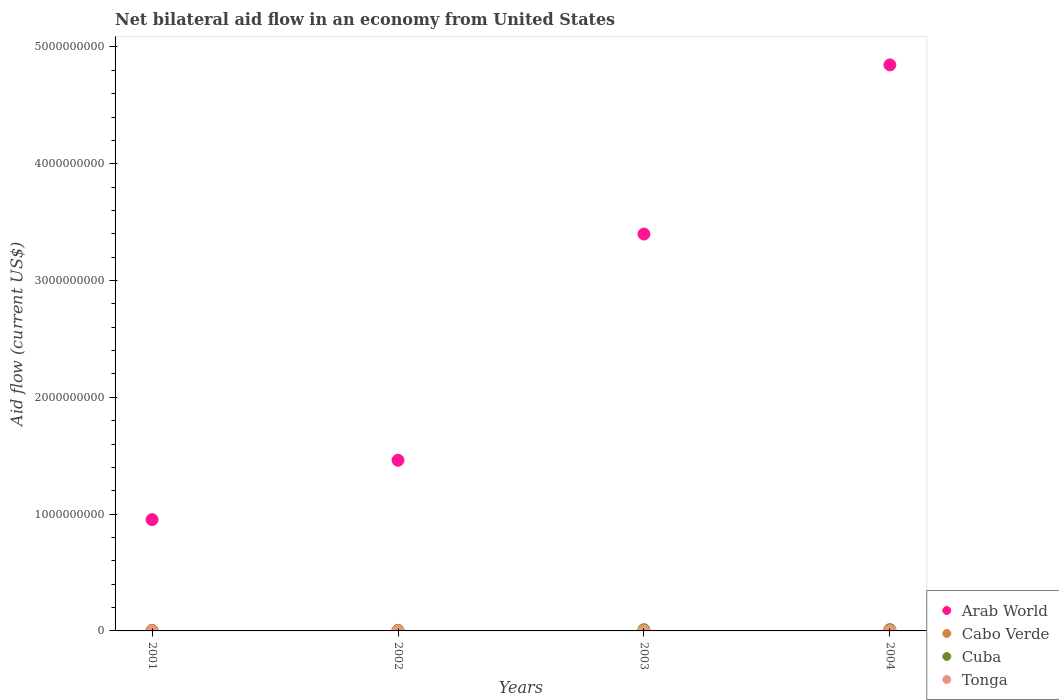How many different coloured dotlines are there?
Your response must be concise. 4. What is the net bilateral aid flow in Arab World in 2004?
Give a very brief answer. 4.85e+09. Across all years, what is the maximum net bilateral aid flow in Arab World?
Keep it short and to the point. 4.85e+09. Across all years, what is the minimum net bilateral aid flow in Tonga?
Ensure brevity in your answer.  9.80e+05. In which year was the net bilateral aid flow in Tonga minimum?
Offer a terse response. 2003. What is the total net bilateral aid flow in Tonga in the graph?
Provide a succinct answer. 4.41e+06. What is the difference between the net bilateral aid flow in Cuba in 2001 and that in 2004?
Make the answer very short. -6.93e+06. What is the difference between the net bilateral aid flow in Cuba in 2003 and the net bilateral aid flow in Cabo Verde in 2001?
Your response must be concise. 5.89e+06. What is the average net bilateral aid flow in Cuba per year?
Give a very brief answer. 7.22e+06. In the year 2003, what is the difference between the net bilateral aid flow in Cabo Verde and net bilateral aid flow in Arab World?
Keep it short and to the point. -3.39e+09. In how many years, is the net bilateral aid flow in Tonga greater than 600000000 US$?
Your answer should be compact. 0. What is the ratio of the net bilateral aid flow in Arab World in 2001 to that in 2002?
Give a very brief answer. 0.65. Is the difference between the net bilateral aid flow in Cabo Verde in 2002 and 2004 greater than the difference between the net bilateral aid flow in Arab World in 2002 and 2004?
Your answer should be very brief. Yes. What is the difference between the highest and the second highest net bilateral aid flow in Cabo Verde?
Your answer should be very brief. 1.04e+06. What is the difference between the highest and the lowest net bilateral aid flow in Cabo Verde?
Make the answer very short. 2.41e+06. Is it the case that in every year, the sum of the net bilateral aid flow in Cuba and net bilateral aid flow in Tonga  is greater than the net bilateral aid flow in Cabo Verde?
Give a very brief answer. Yes. What is the difference between two consecutive major ticks on the Y-axis?
Ensure brevity in your answer.  1.00e+09. How many legend labels are there?
Offer a terse response. 4. What is the title of the graph?
Your answer should be compact. Net bilateral aid flow in an economy from United States. What is the label or title of the X-axis?
Your answer should be compact. Years. What is the Aid flow (current US$) of Arab World in 2001?
Your response must be concise. 9.53e+08. What is the Aid flow (current US$) in Cabo Verde in 2001?
Ensure brevity in your answer.  4.28e+06. What is the Aid flow (current US$) in Cuba in 2001?
Your answer should be very brief. 3.62e+06. What is the Aid flow (current US$) in Tonga in 2001?
Keep it short and to the point. 1.19e+06. What is the Aid flow (current US$) of Arab World in 2002?
Make the answer very short. 1.46e+09. What is the Aid flow (current US$) of Cabo Verde in 2002?
Provide a short and direct response. 5.01e+06. What is the Aid flow (current US$) in Cuba in 2002?
Make the answer very short. 4.55e+06. What is the Aid flow (current US$) in Tonga in 2002?
Your answer should be compact. 1.15e+06. What is the Aid flow (current US$) of Arab World in 2003?
Offer a very short reply. 3.40e+09. What is the Aid flow (current US$) in Cabo Verde in 2003?
Offer a terse response. 5.65e+06. What is the Aid flow (current US$) in Cuba in 2003?
Keep it short and to the point. 1.02e+07. What is the Aid flow (current US$) of Tonga in 2003?
Ensure brevity in your answer.  9.80e+05. What is the Aid flow (current US$) of Arab World in 2004?
Offer a very short reply. 4.85e+09. What is the Aid flow (current US$) in Cabo Verde in 2004?
Provide a succinct answer. 6.69e+06. What is the Aid flow (current US$) in Cuba in 2004?
Your response must be concise. 1.06e+07. What is the Aid flow (current US$) in Tonga in 2004?
Make the answer very short. 1.09e+06. Across all years, what is the maximum Aid flow (current US$) in Arab World?
Your answer should be compact. 4.85e+09. Across all years, what is the maximum Aid flow (current US$) in Cabo Verde?
Offer a terse response. 6.69e+06. Across all years, what is the maximum Aid flow (current US$) of Cuba?
Offer a terse response. 1.06e+07. Across all years, what is the maximum Aid flow (current US$) in Tonga?
Your answer should be compact. 1.19e+06. Across all years, what is the minimum Aid flow (current US$) of Arab World?
Your answer should be very brief. 9.53e+08. Across all years, what is the minimum Aid flow (current US$) of Cabo Verde?
Your answer should be very brief. 4.28e+06. Across all years, what is the minimum Aid flow (current US$) of Cuba?
Your answer should be compact. 3.62e+06. Across all years, what is the minimum Aid flow (current US$) in Tonga?
Your response must be concise. 9.80e+05. What is the total Aid flow (current US$) in Arab World in the graph?
Offer a terse response. 1.07e+1. What is the total Aid flow (current US$) of Cabo Verde in the graph?
Your answer should be very brief. 2.16e+07. What is the total Aid flow (current US$) in Cuba in the graph?
Provide a succinct answer. 2.89e+07. What is the total Aid flow (current US$) of Tonga in the graph?
Keep it short and to the point. 4.41e+06. What is the difference between the Aid flow (current US$) in Arab World in 2001 and that in 2002?
Keep it short and to the point. -5.08e+08. What is the difference between the Aid flow (current US$) of Cabo Verde in 2001 and that in 2002?
Offer a terse response. -7.30e+05. What is the difference between the Aid flow (current US$) in Cuba in 2001 and that in 2002?
Your answer should be very brief. -9.30e+05. What is the difference between the Aid flow (current US$) in Tonga in 2001 and that in 2002?
Provide a short and direct response. 4.00e+04. What is the difference between the Aid flow (current US$) in Arab World in 2001 and that in 2003?
Make the answer very short. -2.45e+09. What is the difference between the Aid flow (current US$) in Cabo Verde in 2001 and that in 2003?
Your answer should be compact. -1.37e+06. What is the difference between the Aid flow (current US$) in Cuba in 2001 and that in 2003?
Provide a succinct answer. -6.55e+06. What is the difference between the Aid flow (current US$) of Arab World in 2001 and that in 2004?
Give a very brief answer. -3.89e+09. What is the difference between the Aid flow (current US$) in Cabo Verde in 2001 and that in 2004?
Give a very brief answer. -2.41e+06. What is the difference between the Aid flow (current US$) in Cuba in 2001 and that in 2004?
Your answer should be very brief. -6.93e+06. What is the difference between the Aid flow (current US$) in Tonga in 2001 and that in 2004?
Give a very brief answer. 1.00e+05. What is the difference between the Aid flow (current US$) of Arab World in 2002 and that in 2003?
Offer a very short reply. -1.94e+09. What is the difference between the Aid flow (current US$) of Cabo Verde in 2002 and that in 2003?
Provide a short and direct response. -6.40e+05. What is the difference between the Aid flow (current US$) of Cuba in 2002 and that in 2003?
Provide a short and direct response. -5.62e+06. What is the difference between the Aid flow (current US$) in Arab World in 2002 and that in 2004?
Make the answer very short. -3.39e+09. What is the difference between the Aid flow (current US$) of Cabo Verde in 2002 and that in 2004?
Ensure brevity in your answer.  -1.68e+06. What is the difference between the Aid flow (current US$) in Cuba in 2002 and that in 2004?
Keep it short and to the point. -6.00e+06. What is the difference between the Aid flow (current US$) in Tonga in 2002 and that in 2004?
Provide a succinct answer. 6.00e+04. What is the difference between the Aid flow (current US$) of Arab World in 2003 and that in 2004?
Keep it short and to the point. -1.45e+09. What is the difference between the Aid flow (current US$) in Cabo Verde in 2003 and that in 2004?
Your answer should be very brief. -1.04e+06. What is the difference between the Aid flow (current US$) of Cuba in 2003 and that in 2004?
Ensure brevity in your answer.  -3.80e+05. What is the difference between the Aid flow (current US$) in Arab World in 2001 and the Aid flow (current US$) in Cabo Verde in 2002?
Make the answer very short. 9.48e+08. What is the difference between the Aid flow (current US$) in Arab World in 2001 and the Aid flow (current US$) in Cuba in 2002?
Ensure brevity in your answer.  9.48e+08. What is the difference between the Aid flow (current US$) of Arab World in 2001 and the Aid flow (current US$) of Tonga in 2002?
Offer a very short reply. 9.52e+08. What is the difference between the Aid flow (current US$) in Cabo Verde in 2001 and the Aid flow (current US$) in Tonga in 2002?
Provide a short and direct response. 3.13e+06. What is the difference between the Aid flow (current US$) of Cuba in 2001 and the Aid flow (current US$) of Tonga in 2002?
Give a very brief answer. 2.47e+06. What is the difference between the Aid flow (current US$) in Arab World in 2001 and the Aid flow (current US$) in Cabo Verde in 2003?
Your response must be concise. 9.47e+08. What is the difference between the Aid flow (current US$) in Arab World in 2001 and the Aid flow (current US$) in Cuba in 2003?
Your answer should be compact. 9.43e+08. What is the difference between the Aid flow (current US$) in Arab World in 2001 and the Aid flow (current US$) in Tonga in 2003?
Your answer should be very brief. 9.52e+08. What is the difference between the Aid flow (current US$) of Cabo Verde in 2001 and the Aid flow (current US$) of Cuba in 2003?
Keep it short and to the point. -5.89e+06. What is the difference between the Aid flow (current US$) in Cabo Verde in 2001 and the Aid flow (current US$) in Tonga in 2003?
Provide a short and direct response. 3.30e+06. What is the difference between the Aid flow (current US$) of Cuba in 2001 and the Aid flow (current US$) of Tonga in 2003?
Make the answer very short. 2.64e+06. What is the difference between the Aid flow (current US$) in Arab World in 2001 and the Aid flow (current US$) in Cabo Verde in 2004?
Provide a short and direct response. 9.46e+08. What is the difference between the Aid flow (current US$) in Arab World in 2001 and the Aid flow (current US$) in Cuba in 2004?
Offer a terse response. 9.42e+08. What is the difference between the Aid flow (current US$) of Arab World in 2001 and the Aid flow (current US$) of Tonga in 2004?
Your answer should be very brief. 9.52e+08. What is the difference between the Aid flow (current US$) of Cabo Verde in 2001 and the Aid flow (current US$) of Cuba in 2004?
Provide a short and direct response. -6.27e+06. What is the difference between the Aid flow (current US$) of Cabo Verde in 2001 and the Aid flow (current US$) of Tonga in 2004?
Make the answer very short. 3.19e+06. What is the difference between the Aid flow (current US$) of Cuba in 2001 and the Aid flow (current US$) of Tonga in 2004?
Your answer should be compact. 2.53e+06. What is the difference between the Aid flow (current US$) in Arab World in 2002 and the Aid flow (current US$) in Cabo Verde in 2003?
Keep it short and to the point. 1.46e+09. What is the difference between the Aid flow (current US$) in Arab World in 2002 and the Aid flow (current US$) in Cuba in 2003?
Provide a succinct answer. 1.45e+09. What is the difference between the Aid flow (current US$) of Arab World in 2002 and the Aid flow (current US$) of Tonga in 2003?
Provide a short and direct response. 1.46e+09. What is the difference between the Aid flow (current US$) of Cabo Verde in 2002 and the Aid flow (current US$) of Cuba in 2003?
Your response must be concise. -5.16e+06. What is the difference between the Aid flow (current US$) of Cabo Verde in 2002 and the Aid flow (current US$) of Tonga in 2003?
Offer a terse response. 4.03e+06. What is the difference between the Aid flow (current US$) of Cuba in 2002 and the Aid flow (current US$) of Tonga in 2003?
Offer a terse response. 3.57e+06. What is the difference between the Aid flow (current US$) of Arab World in 2002 and the Aid flow (current US$) of Cabo Verde in 2004?
Ensure brevity in your answer.  1.45e+09. What is the difference between the Aid flow (current US$) of Arab World in 2002 and the Aid flow (current US$) of Cuba in 2004?
Your answer should be very brief. 1.45e+09. What is the difference between the Aid flow (current US$) of Arab World in 2002 and the Aid flow (current US$) of Tonga in 2004?
Your answer should be very brief. 1.46e+09. What is the difference between the Aid flow (current US$) of Cabo Verde in 2002 and the Aid flow (current US$) of Cuba in 2004?
Make the answer very short. -5.54e+06. What is the difference between the Aid flow (current US$) of Cabo Verde in 2002 and the Aid flow (current US$) of Tonga in 2004?
Keep it short and to the point. 3.92e+06. What is the difference between the Aid flow (current US$) of Cuba in 2002 and the Aid flow (current US$) of Tonga in 2004?
Keep it short and to the point. 3.46e+06. What is the difference between the Aid flow (current US$) in Arab World in 2003 and the Aid flow (current US$) in Cabo Verde in 2004?
Your response must be concise. 3.39e+09. What is the difference between the Aid flow (current US$) of Arab World in 2003 and the Aid flow (current US$) of Cuba in 2004?
Your answer should be very brief. 3.39e+09. What is the difference between the Aid flow (current US$) of Arab World in 2003 and the Aid flow (current US$) of Tonga in 2004?
Your answer should be very brief. 3.40e+09. What is the difference between the Aid flow (current US$) in Cabo Verde in 2003 and the Aid flow (current US$) in Cuba in 2004?
Keep it short and to the point. -4.90e+06. What is the difference between the Aid flow (current US$) of Cabo Verde in 2003 and the Aid flow (current US$) of Tonga in 2004?
Give a very brief answer. 4.56e+06. What is the difference between the Aid flow (current US$) of Cuba in 2003 and the Aid flow (current US$) of Tonga in 2004?
Your response must be concise. 9.08e+06. What is the average Aid flow (current US$) in Arab World per year?
Your answer should be compact. 2.66e+09. What is the average Aid flow (current US$) of Cabo Verde per year?
Offer a terse response. 5.41e+06. What is the average Aid flow (current US$) in Cuba per year?
Offer a very short reply. 7.22e+06. What is the average Aid flow (current US$) in Tonga per year?
Keep it short and to the point. 1.10e+06. In the year 2001, what is the difference between the Aid flow (current US$) of Arab World and Aid flow (current US$) of Cabo Verde?
Offer a terse response. 9.48e+08. In the year 2001, what is the difference between the Aid flow (current US$) in Arab World and Aid flow (current US$) in Cuba?
Give a very brief answer. 9.49e+08. In the year 2001, what is the difference between the Aid flow (current US$) in Arab World and Aid flow (current US$) in Tonga?
Your answer should be compact. 9.52e+08. In the year 2001, what is the difference between the Aid flow (current US$) in Cabo Verde and Aid flow (current US$) in Cuba?
Give a very brief answer. 6.60e+05. In the year 2001, what is the difference between the Aid flow (current US$) of Cabo Verde and Aid flow (current US$) of Tonga?
Provide a succinct answer. 3.09e+06. In the year 2001, what is the difference between the Aid flow (current US$) in Cuba and Aid flow (current US$) in Tonga?
Keep it short and to the point. 2.43e+06. In the year 2002, what is the difference between the Aid flow (current US$) in Arab World and Aid flow (current US$) in Cabo Verde?
Keep it short and to the point. 1.46e+09. In the year 2002, what is the difference between the Aid flow (current US$) of Arab World and Aid flow (current US$) of Cuba?
Give a very brief answer. 1.46e+09. In the year 2002, what is the difference between the Aid flow (current US$) in Arab World and Aid flow (current US$) in Tonga?
Offer a very short reply. 1.46e+09. In the year 2002, what is the difference between the Aid flow (current US$) of Cabo Verde and Aid flow (current US$) of Tonga?
Offer a very short reply. 3.86e+06. In the year 2002, what is the difference between the Aid flow (current US$) in Cuba and Aid flow (current US$) in Tonga?
Provide a short and direct response. 3.40e+06. In the year 2003, what is the difference between the Aid flow (current US$) of Arab World and Aid flow (current US$) of Cabo Verde?
Provide a succinct answer. 3.39e+09. In the year 2003, what is the difference between the Aid flow (current US$) of Arab World and Aid flow (current US$) of Cuba?
Give a very brief answer. 3.39e+09. In the year 2003, what is the difference between the Aid flow (current US$) in Arab World and Aid flow (current US$) in Tonga?
Offer a very short reply. 3.40e+09. In the year 2003, what is the difference between the Aid flow (current US$) of Cabo Verde and Aid flow (current US$) of Cuba?
Offer a very short reply. -4.52e+06. In the year 2003, what is the difference between the Aid flow (current US$) of Cabo Verde and Aid flow (current US$) of Tonga?
Make the answer very short. 4.67e+06. In the year 2003, what is the difference between the Aid flow (current US$) in Cuba and Aid flow (current US$) in Tonga?
Keep it short and to the point. 9.19e+06. In the year 2004, what is the difference between the Aid flow (current US$) of Arab World and Aid flow (current US$) of Cabo Verde?
Your answer should be very brief. 4.84e+09. In the year 2004, what is the difference between the Aid flow (current US$) in Arab World and Aid flow (current US$) in Cuba?
Your answer should be very brief. 4.84e+09. In the year 2004, what is the difference between the Aid flow (current US$) in Arab World and Aid flow (current US$) in Tonga?
Your answer should be compact. 4.85e+09. In the year 2004, what is the difference between the Aid flow (current US$) of Cabo Verde and Aid flow (current US$) of Cuba?
Your answer should be very brief. -3.86e+06. In the year 2004, what is the difference between the Aid flow (current US$) in Cabo Verde and Aid flow (current US$) in Tonga?
Keep it short and to the point. 5.60e+06. In the year 2004, what is the difference between the Aid flow (current US$) in Cuba and Aid flow (current US$) in Tonga?
Your response must be concise. 9.46e+06. What is the ratio of the Aid flow (current US$) in Arab World in 2001 to that in 2002?
Offer a very short reply. 0.65. What is the ratio of the Aid flow (current US$) of Cabo Verde in 2001 to that in 2002?
Provide a succinct answer. 0.85. What is the ratio of the Aid flow (current US$) of Cuba in 2001 to that in 2002?
Offer a terse response. 0.8. What is the ratio of the Aid flow (current US$) of Tonga in 2001 to that in 2002?
Offer a terse response. 1.03. What is the ratio of the Aid flow (current US$) of Arab World in 2001 to that in 2003?
Give a very brief answer. 0.28. What is the ratio of the Aid flow (current US$) of Cabo Verde in 2001 to that in 2003?
Your answer should be very brief. 0.76. What is the ratio of the Aid flow (current US$) in Cuba in 2001 to that in 2003?
Offer a terse response. 0.36. What is the ratio of the Aid flow (current US$) in Tonga in 2001 to that in 2003?
Provide a succinct answer. 1.21. What is the ratio of the Aid flow (current US$) in Arab World in 2001 to that in 2004?
Offer a very short reply. 0.2. What is the ratio of the Aid flow (current US$) in Cabo Verde in 2001 to that in 2004?
Offer a terse response. 0.64. What is the ratio of the Aid flow (current US$) of Cuba in 2001 to that in 2004?
Offer a very short reply. 0.34. What is the ratio of the Aid flow (current US$) of Tonga in 2001 to that in 2004?
Give a very brief answer. 1.09. What is the ratio of the Aid flow (current US$) of Arab World in 2002 to that in 2003?
Keep it short and to the point. 0.43. What is the ratio of the Aid flow (current US$) of Cabo Verde in 2002 to that in 2003?
Your answer should be very brief. 0.89. What is the ratio of the Aid flow (current US$) in Cuba in 2002 to that in 2003?
Your answer should be compact. 0.45. What is the ratio of the Aid flow (current US$) of Tonga in 2002 to that in 2003?
Provide a short and direct response. 1.17. What is the ratio of the Aid flow (current US$) in Arab World in 2002 to that in 2004?
Your answer should be compact. 0.3. What is the ratio of the Aid flow (current US$) of Cabo Verde in 2002 to that in 2004?
Give a very brief answer. 0.75. What is the ratio of the Aid flow (current US$) of Cuba in 2002 to that in 2004?
Your response must be concise. 0.43. What is the ratio of the Aid flow (current US$) in Tonga in 2002 to that in 2004?
Give a very brief answer. 1.05. What is the ratio of the Aid flow (current US$) of Arab World in 2003 to that in 2004?
Provide a short and direct response. 0.7. What is the ratio of the Aid flow (current US$) of Cabo Verde in 2003 to that in 2004?
Offer a very short reply. 0.84. What is the ratio of the Aid flow (current US$) of Tonga in 2003 to that in 2004?
Offer a terse response. 0.9. What is the difference between the highest and the second highest Aid flow (current US$) of Arab World?
Offer a terse response. 1.45e+09. What is the difference between the highest and the second highest Aid flow (current US$) in Cabo Verde?
Offer a very short reply. 1.04e+06. What is the difference between the highest and the second highest Aid flow (current US$) in Tonga?
Offer a terse response. 4.00e+04. What is the difference between the highest and the lowest Aid flow (current US$) in Arab World?
Offer a terse response. 3.89e+09. What is the difference between the highest and the lowest Aid flow (current US$) in Cabo Verde?
Your answer should be very brief. 2.41e+06. What is the difference between the highest and the lowest Aid flow (current US$) in Cuba?
Provide a short and direct response. 6.93e+06. 